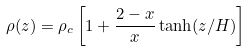Convert formula to latex. <formula><loc_0><loc_0><loc_500><loc_500>\rho ( z ) = \rho _ { c } \left [ 1 + \frac { 2 - x } { x } \tanh ( z / H ) \right ]</formula> 